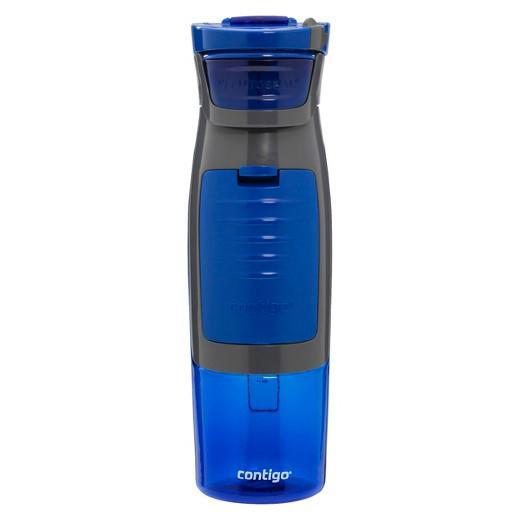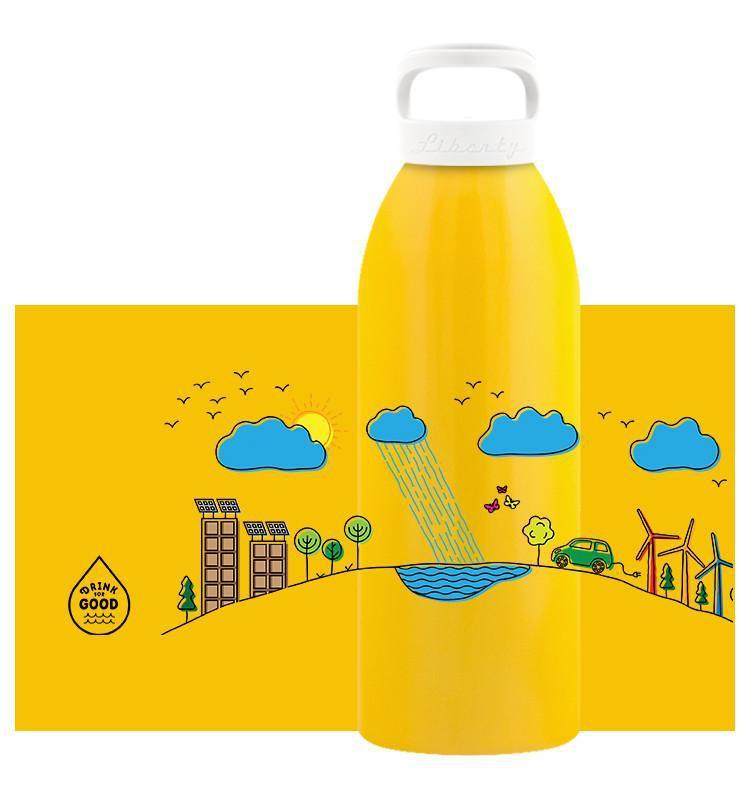The first image is the image on the left, the second image is the image on the right. Assess this claim about the two images: "Out of the two bottles, one is blue.". Correct or not? Answer yes or no. Yes. The first image is the image on the left, the second image is the image on the right. For the images displayed, is the sentence "An image contains exactly one vivid purple upright water bottle." factually correct? Answer yes or no. No. 